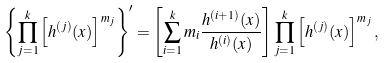<formula> <loc_0><loc_0><loc_500><loc_500>\left \{ \prod _ { j = 1 } ^ { k } \left [ h ^ { ( j ) } ( x ) \right ] ^ { m _ { j } } \right \} ^ { \prime } = \left [ \sum _ { i = 1 } ^ { k } m _ { i } \frac { h ^ { ( i + 1 ) } ( x ) } { h ^ { ( i ) } ( x ) } \right ] \prod _ { j = 1 } ^ { k } \left [ h ^ { ( j ) } ( x ) \right ] ^ { m _ { j } } ,</formula> 